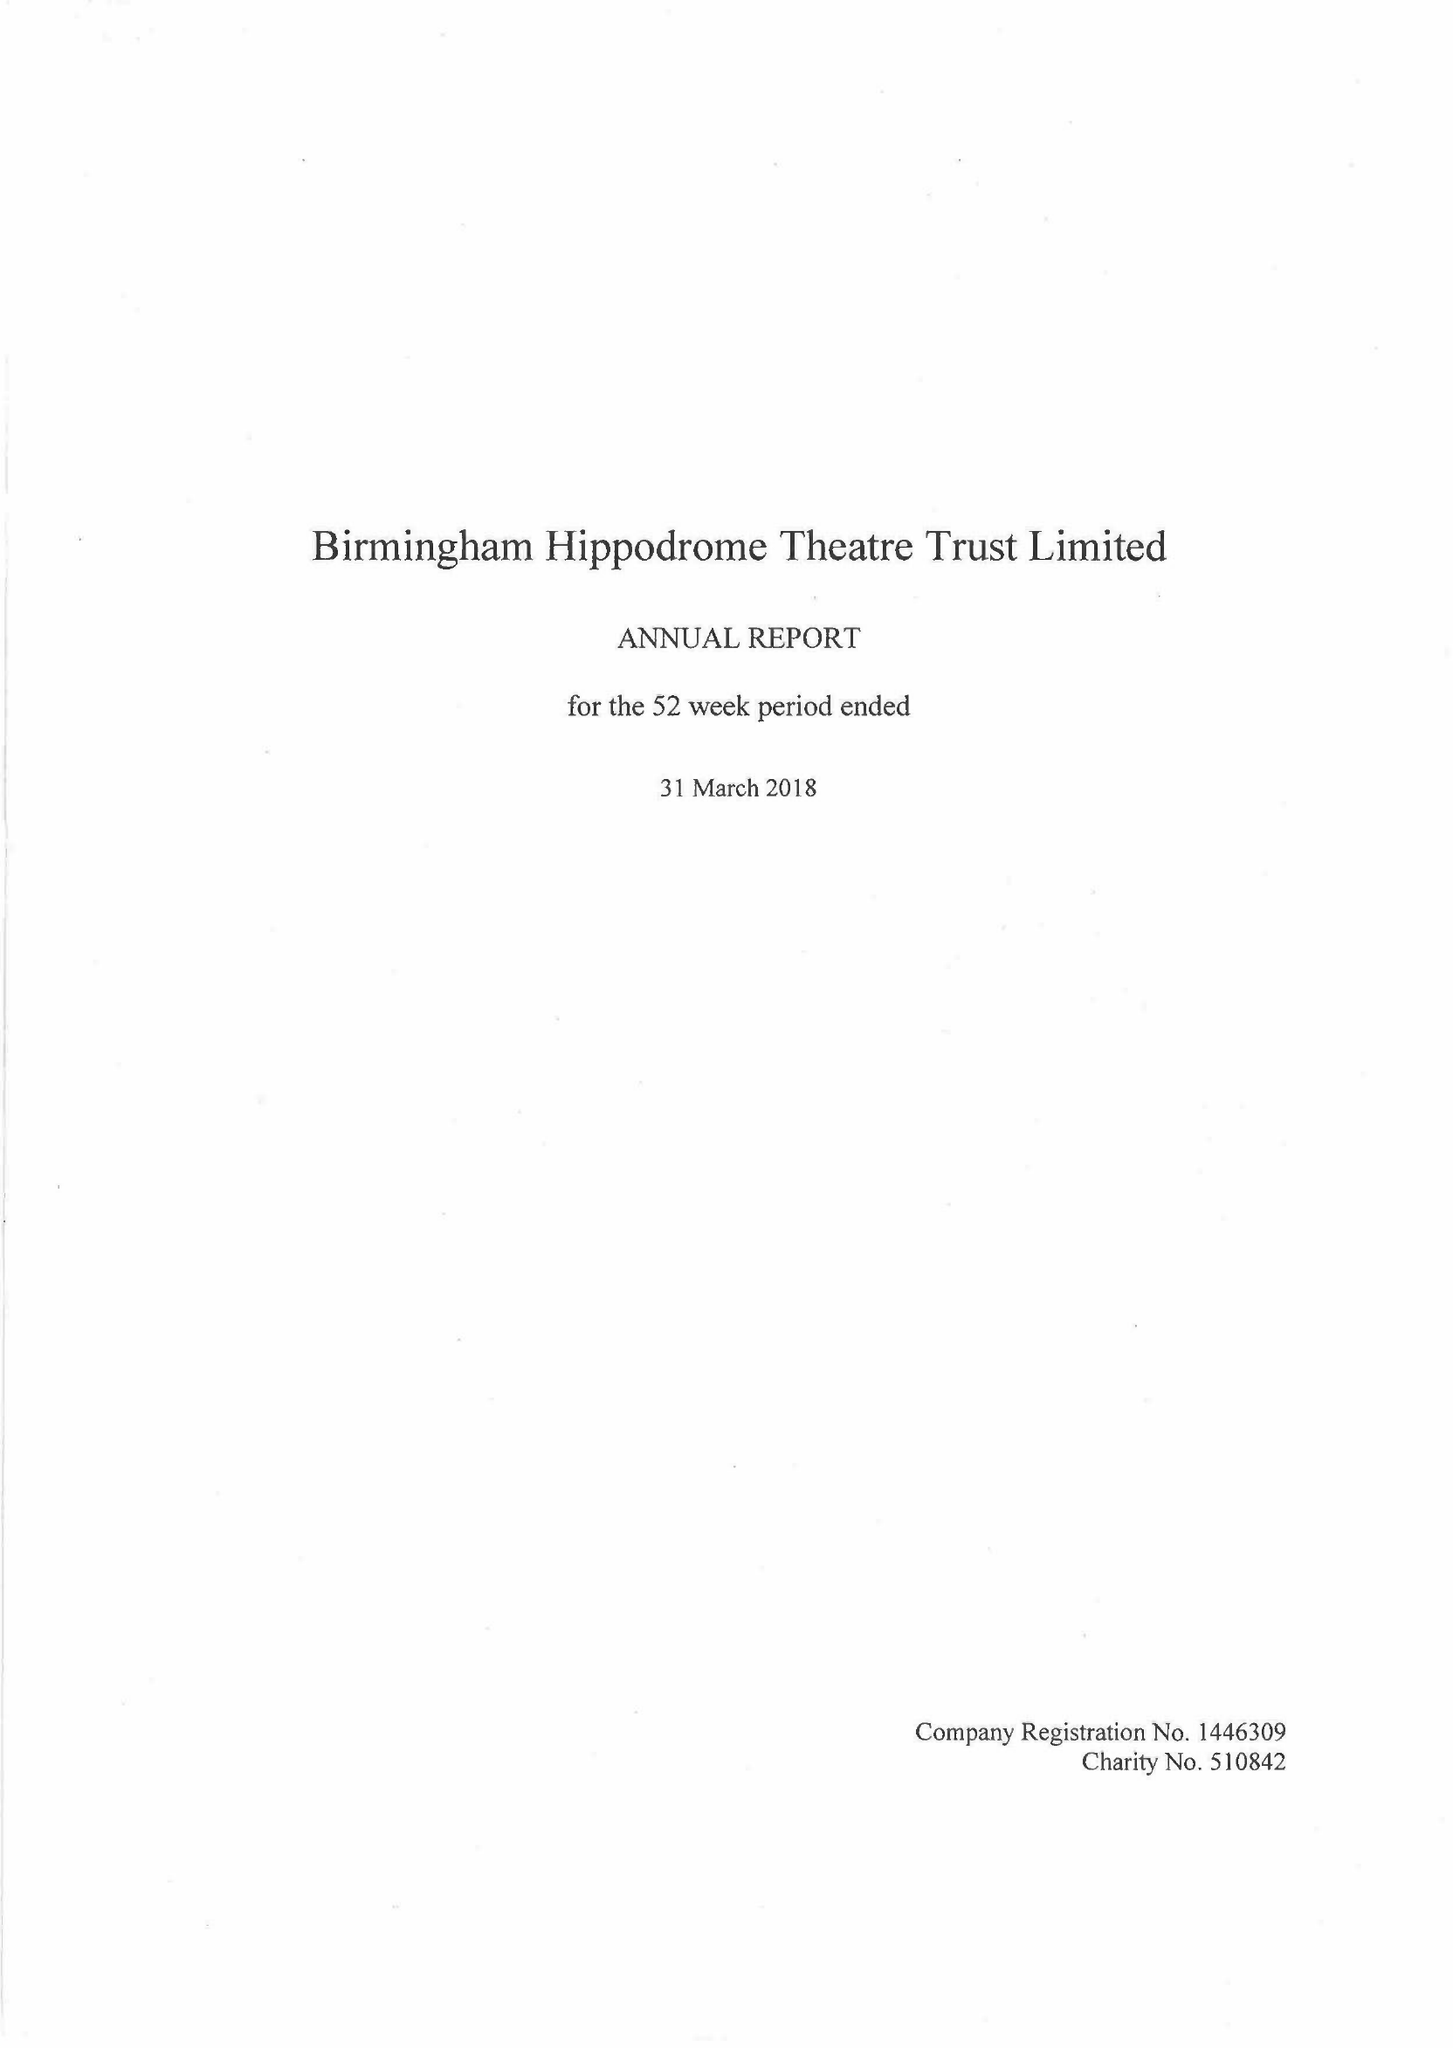What is the value for the address__street_line?
Answer the question using a single word or phrase. HURST STREET 